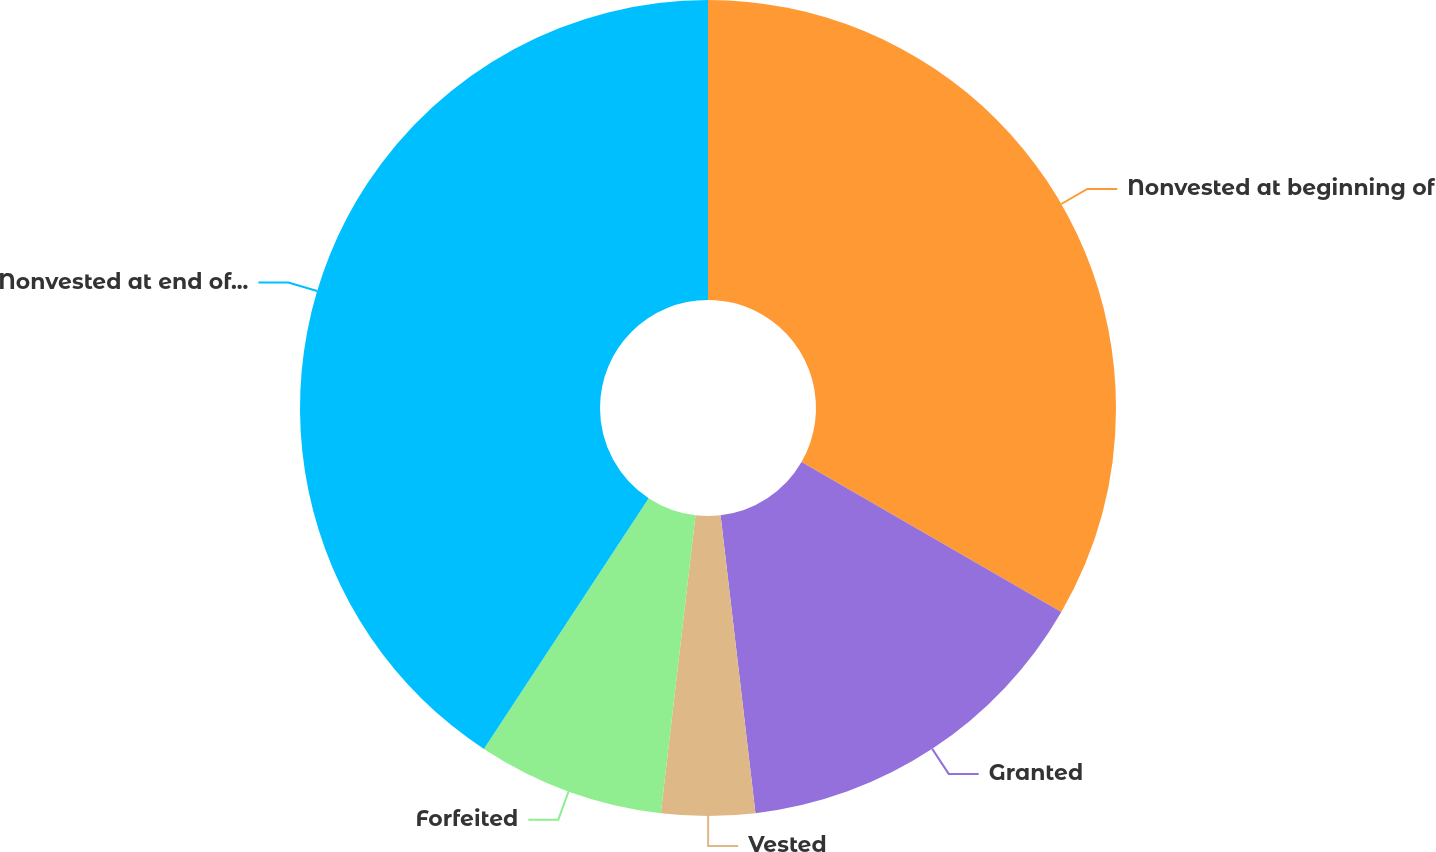<chart> <loc_0><loc_0><loc_500><loc_500><pie_chart><fcel>Nonvested at beginning of<fcel>Granted<fcel>Vested<fcel>Forfeited<fcel>Nonvested at end of period<nl><fcel>33.33%<fcel>14.81%<fcel>3.7%<fcel>7.41%<fcel>40.74%<nl></chart> 